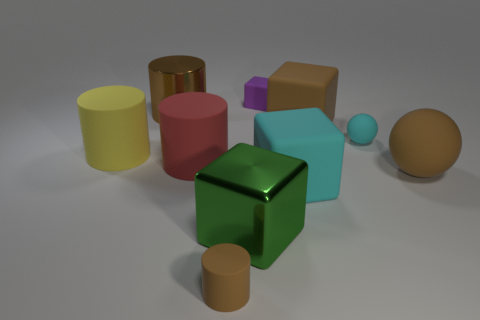Subtract all brown metallic cylinders. How many cylinders are left? 3 Subtract all green balls. How many brown cylinders are left? 2 Subtract all cyan blocks. How many blocks are left? 3 Subtract 3 cylinders. How many cylinders are left? 1 Subtract all cylinders. How many objects are left? 6 Subtract all red balls. Subtract all red blocks. How many balls are left? 2 Subtract all large green shiny objects. Subtract all green blocks. How many objects are left? 8 Add 5 cyan matte blocks. How many cyan matte blocks are left? 6 Add 9 tiny green rubber cylinders. How many tiny green rubber cylinders exist? 9 Subtract 0 purple balls. How many objects are left? 10 